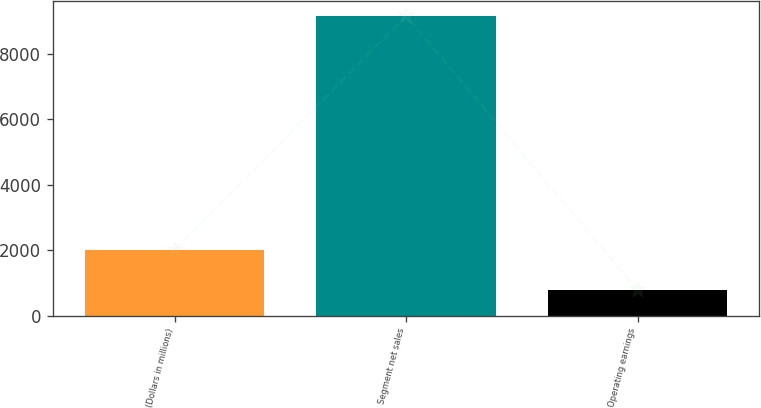Convert chart. <chart><loc_0><loc_0><loc_500><loc_500><bar_chart><fcel>(Dollars in millions)<fcel>Segment net sales<fcel>Operating earnings<nl><fcel>2006<fcel>9164<fcel>787<nl></chart> 